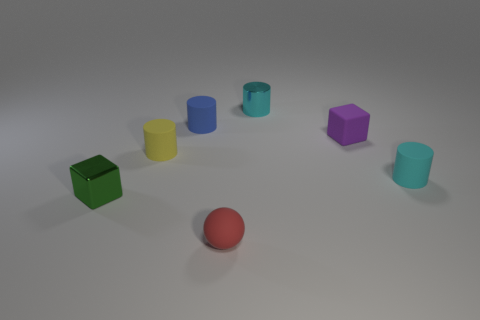The small cube in front of the small rubber cylinder that is right of the red sphere is made of what material?
Provide a succinct answer. Metal. Is the number of tiny green things that are behind the small cyan metal object the same as the number of shiny objects?
Provide a succinct answer. No. Are there any other things that have the same material as the blue object?
Your response must be concise. Yes. There is a metal thing that is to the left of the tiny red rubber object; does it have the same color as the block behind the small metallic cube?
Provide a short and direct response. No. How many small matte cylinders are to the right of the small blue cylinder and to the left of the small blue cylinder?
Keep it short and to the point. 0. How many other things are there of the same shape as the small blue thing?
Your answer should be compact. 3. Is the number of spheres on the right side of the red sphere greater than the number of small metal cylinders?
Offer a very short reply. No. The matte cylinder that is to the right of the small purple matte cube is what color?
Your response must be concise. Cyan. There is a matte object that is the same color as the shiny cylinder; what is its size?
Your response must be concise. Small. What number of rubber objects are either small things or small blue spheres?
Keep it short and to the point. 5. 